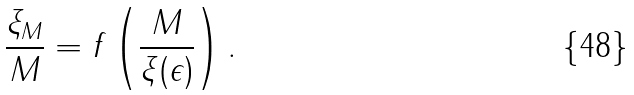<formula> <loc_0><loc_0><loc_500><loc_500>\frac { \xi _ { M } } { M } = f \left ( \frac { M } { \xi ( \epsilon ) } \right ) .</formula> 